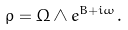<formula> <loc_0><loc_0><loc_500><loc_500>\rho = \Omega \wedge e ^ { B + i \omega } .</formula> 